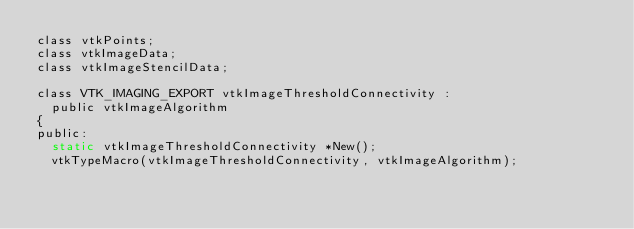<code> <loc_0><loc_0><loc_500><loc_500><_C_>class vtkPoints;
class vtkImageData;
class vtkImageStencilData;

class VTK_IMAGING_EXPORT vtkImageThresholdConnectivity :
  public vtkImageAlgorithm
{
public:
  static vtkImageThresholdConnectivity *New();
  vtkTypeMacro(vtkImageThresholdConnectivity, vtkImageAlgorithm);</code> 